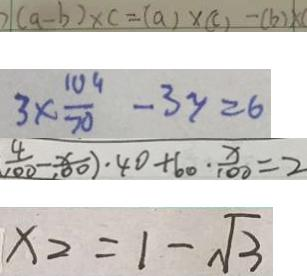Convert formula to latex. <formula><loc_0><loc_0><loc_500><loc_500>2 ( a - b ) \times c = ( a ) \times ( c ) - ( b ) \times c 
 3 \times \frac { 1 0 4 } { 7 0 } - 3 y = 6 
 \frac { 4 } { 1 0 0 } - \frac { x } { 1 0 0 } ) \cdot 4 0 + 6 0 \cdot \frac { x } { 1 0 0 } = 2 
 x _ { 2 } = 1 - \sqrt { 3 }</formula> 